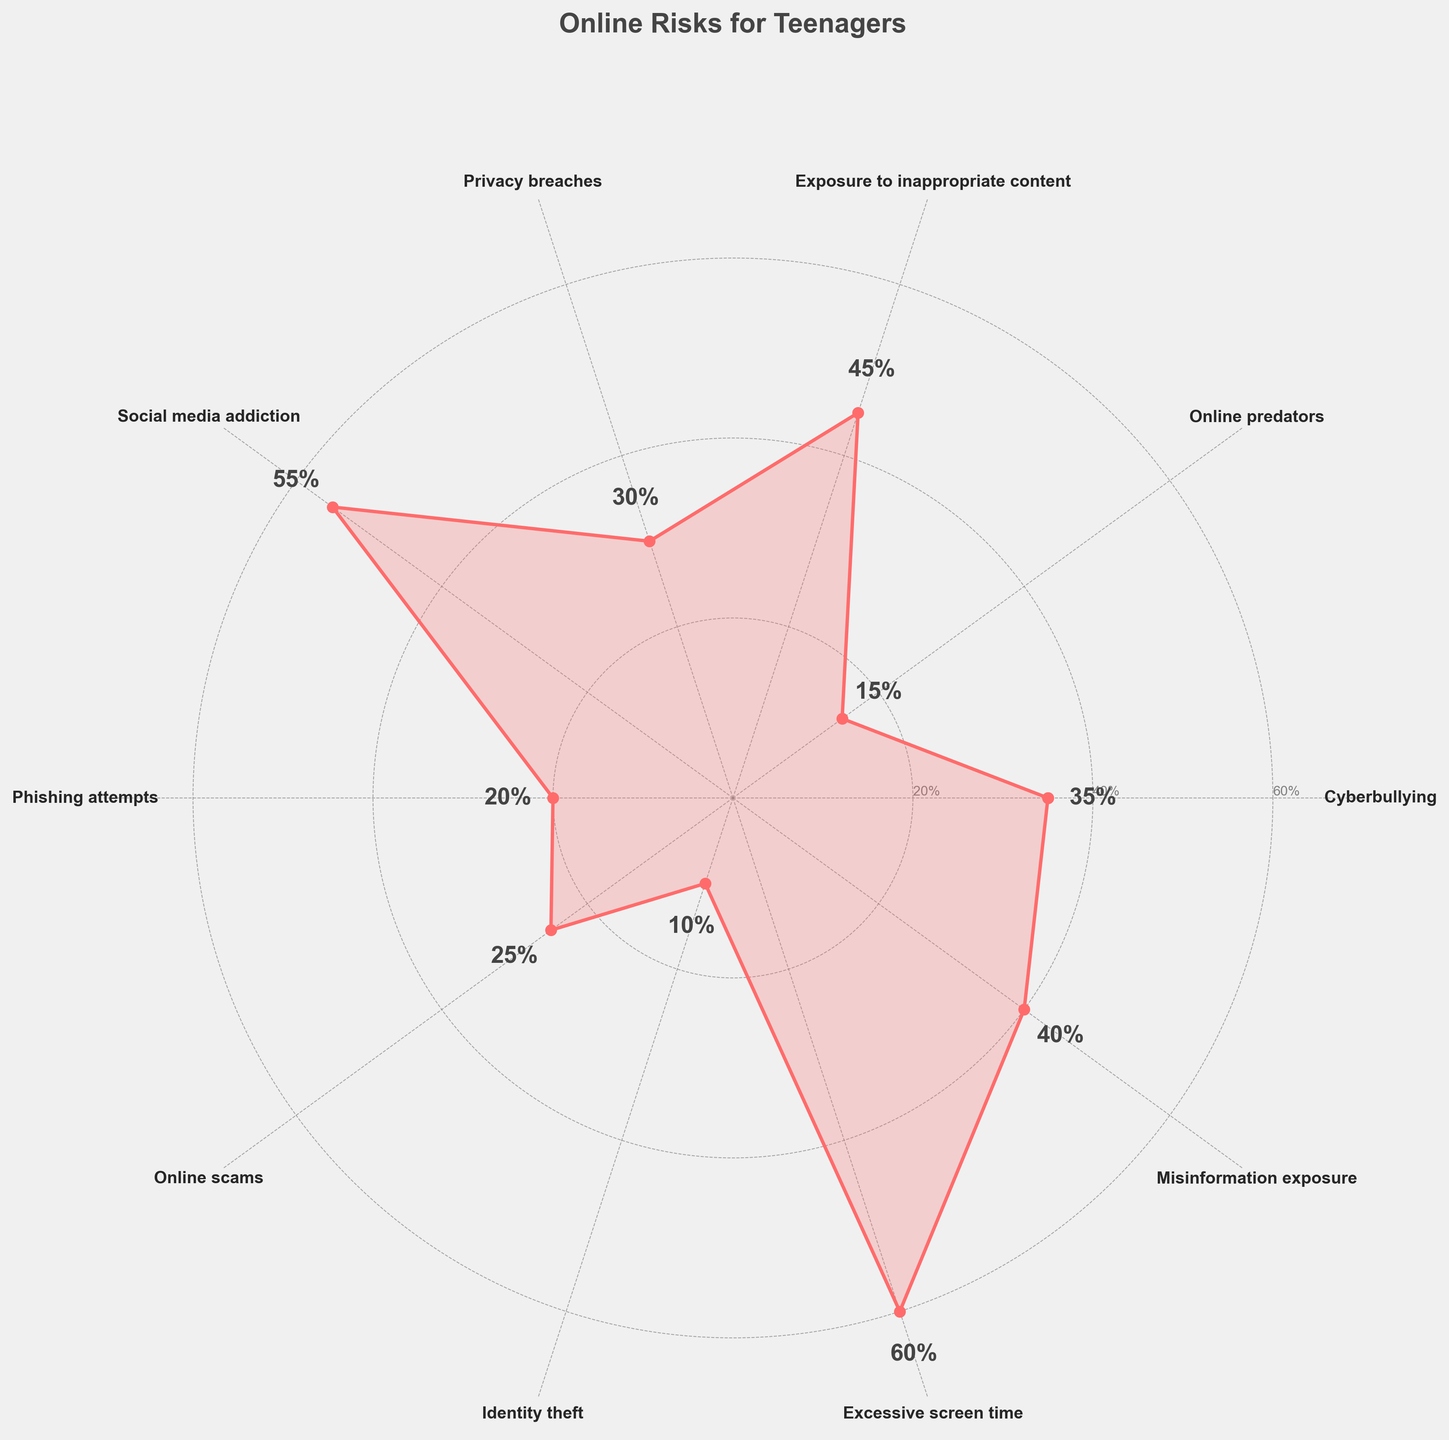What is the title of the figure? The title is typically found at the top of the figure and is designed to summarize the main topic of the chart.
Answer: Online Risks for Teenagers How many categories of online risks are shown in the figure? The number of categories can be determined by counting the labels around the circumference of the polar chart.
Answer: 10 Which online risk has the highest prevalence? To find this, look for the category with the highest percentage value on the chart.
Answer: Excessive screen time What is the percentage of teenagers encountering online predators? This can be read directly from the chart by finding the value associated with "Online predators".
Answer: 15% Compare the prevalence of social media addiction and privacy breaches. Which one is higher and by how much? Determine the values for both categories from the chart and subtract the smaller value from the larger one.
Answer: Social media addiction is higher by 25% (55% vs 30%) Which two online risks have the lowest prevalence? Identify the two categories with the smallest percentage values.
Answer: Identity theft and Online predators What's the average prevalence of all the online risks? Sum all the percentages and divide by the number of categories. (35 + 15 + 45 + 30 + 55 + 20 + 25 + 10 + 60 + 40) / 10
Answer: 33.5% Among the risks of phishing attempts, online scams and misinformation exposure, which is the least prevalent? Look at the chart to compare the values of these three categories and identify the smallest one.
Answer: Phishing attempts What is the total percentage of teenagers encountering either cyberbullying or privacy breaches? Add the percentages for both cyberbullying and privacy breaches.
Answer: 65% (35% + 30%) In terms of visual elements, how are the values of the risks represented in the polar chart? The values are depicted using both lines extending from the center and filled areas within the polar plot, with annotations showing exact percentage values.
Answer: Lines and filled areas 